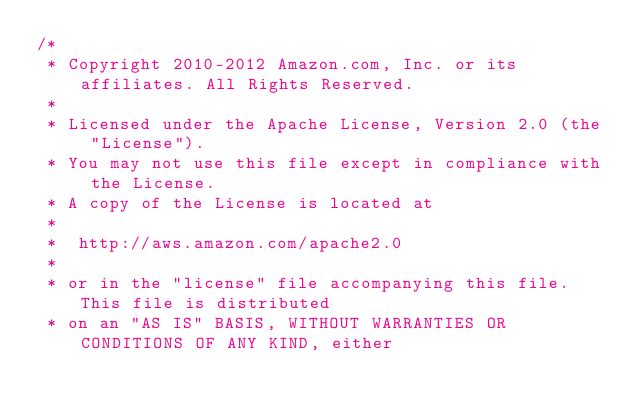<code> <loc_0><loc_0><loc_500><loc_500><_Java_>/*
 * Copyright 2010-2012 Amazon.com, Inc. or its affiliates. All Rights Reserved.
 * 
 * Licensed under the Apache License, Version 2.0 (the "License").
 * You may not use this file except in compliance with the License.
 * A copy of the License is located at
 * 
 *  http://aws.amazon.com/apache2.0
 * 
 * or in the "license" file accompanying this file. This file is distributed
 * on an "AS IS" BASIS, WITHOUT WARRANTIES OR CONDITIONS OF ANY KIND, either</code> 